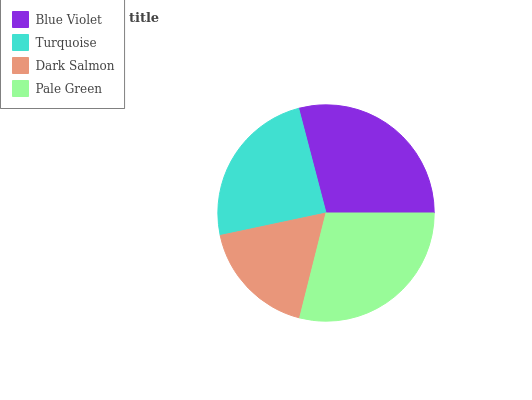Is Dark Salmon the minimum?
Answer yes or no. Yes. Is Blue Violet the maximum?
Answer yes or no. Yes. Is Turquoise the minimum?
Answer yes or no. No. Is Turquoise the maximum?
Answer yes or no. No. Is Blue Violet greater than Turquoise?
Answer yes or no. Yes. Is Turquoise less than Blue Violet?
Answer yes or no. Yes. Is Turquoise greater than Blue Violet?
Answer yes or no. No. Is Blue Violet less than Turquoise?
Answer yes or no. No. Is Pale Green the high median?
Answer yes or no. Yes. Is Turquoise the low median?
Answer yes or no. Yes. Is Blue Violet the high median?
Answer yes or no. No. Is Dark Salmon the low median?
Answer yes or no. No. 